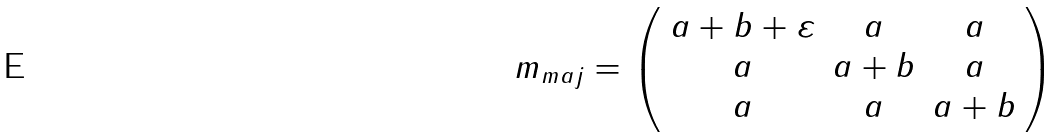Convert formula to latex. <formula><loc_0><loc_0><loc_500><loc_500>m _ { m a j } = \left ( \begin{array} { c c c } a + b + \varepsilon & a & a \\ a & a + b & a \\ a & a & a + b \end{array} \right )</formula> 